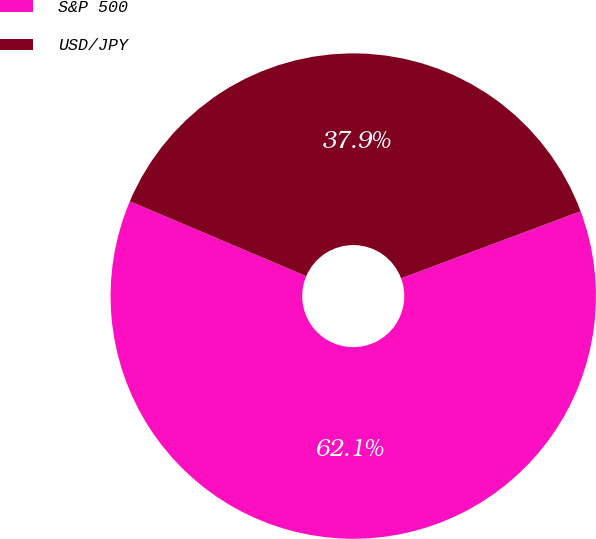Convert chart to OTSL. <chart><loc_0><loc_0><loc_500><loc_500><pie_chart><fcel>S&P 500<fcel>USD/JPY<nl><fcel>62.07%<fcel>37.93%<nl></chart> 